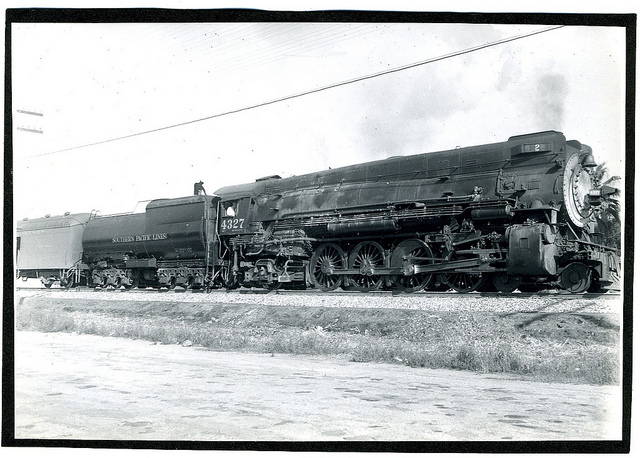What era does the train come from based on its design? This steam locomotive, with its large driving wheels and sleek design, is likely from the first half of the 20th century, a time when steam power was predominant in railroad transportation before diesel engines became more common. 